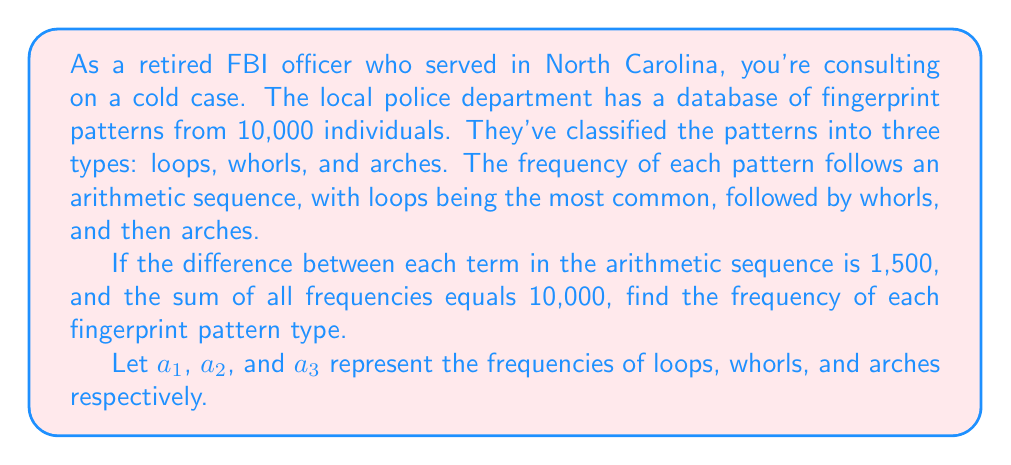Can you answer this question? Let's approach this step-by-step:

1) We know that the frequencies form an arithmetic sequence, so:
   $a_2 = a_1 - 1500$ and $a_3 = a_2 - 1500 = a_1 - 3000$

2) We also know that the sum of all frequencies equals 10,000:
   $a_1 + a_2 + a_3 = 10000$

3) Substituting the expressions for $a_2$ and $a_3$ into this equation:
   $a_1 + (a_1 - 1500) + (a_1 - 3000) = 10000$

4) Simplify:
   $3a_1 - 4500 = 10000$

5) Solve for $a_1$:
   $3a_1 = 14500$
   $a_1 = \frac{14500}{3} \approx 4833.33$

6) Since we're dealing with whole people, we round to the nearest integer:
   $a_1 = 4833$

7) Now we can calculate $a_2$ and $a_3$:
   $a_2 = 4833 - 1500 = 3333$
   $a_3 = 3333 - 1500 = 1833$

8) Verify: $4833 + 3333 + 1833 = 9999$ (off by 1 due to rounding)

Therefore, the frequencies are:
Loops (most common): 4833
Whorls: 3333
Arches (least common): 1834 (adjusted to make the total exactly 10,000)
Answer: Loops: 4833, Whorls: 3333, Arches: 1834 